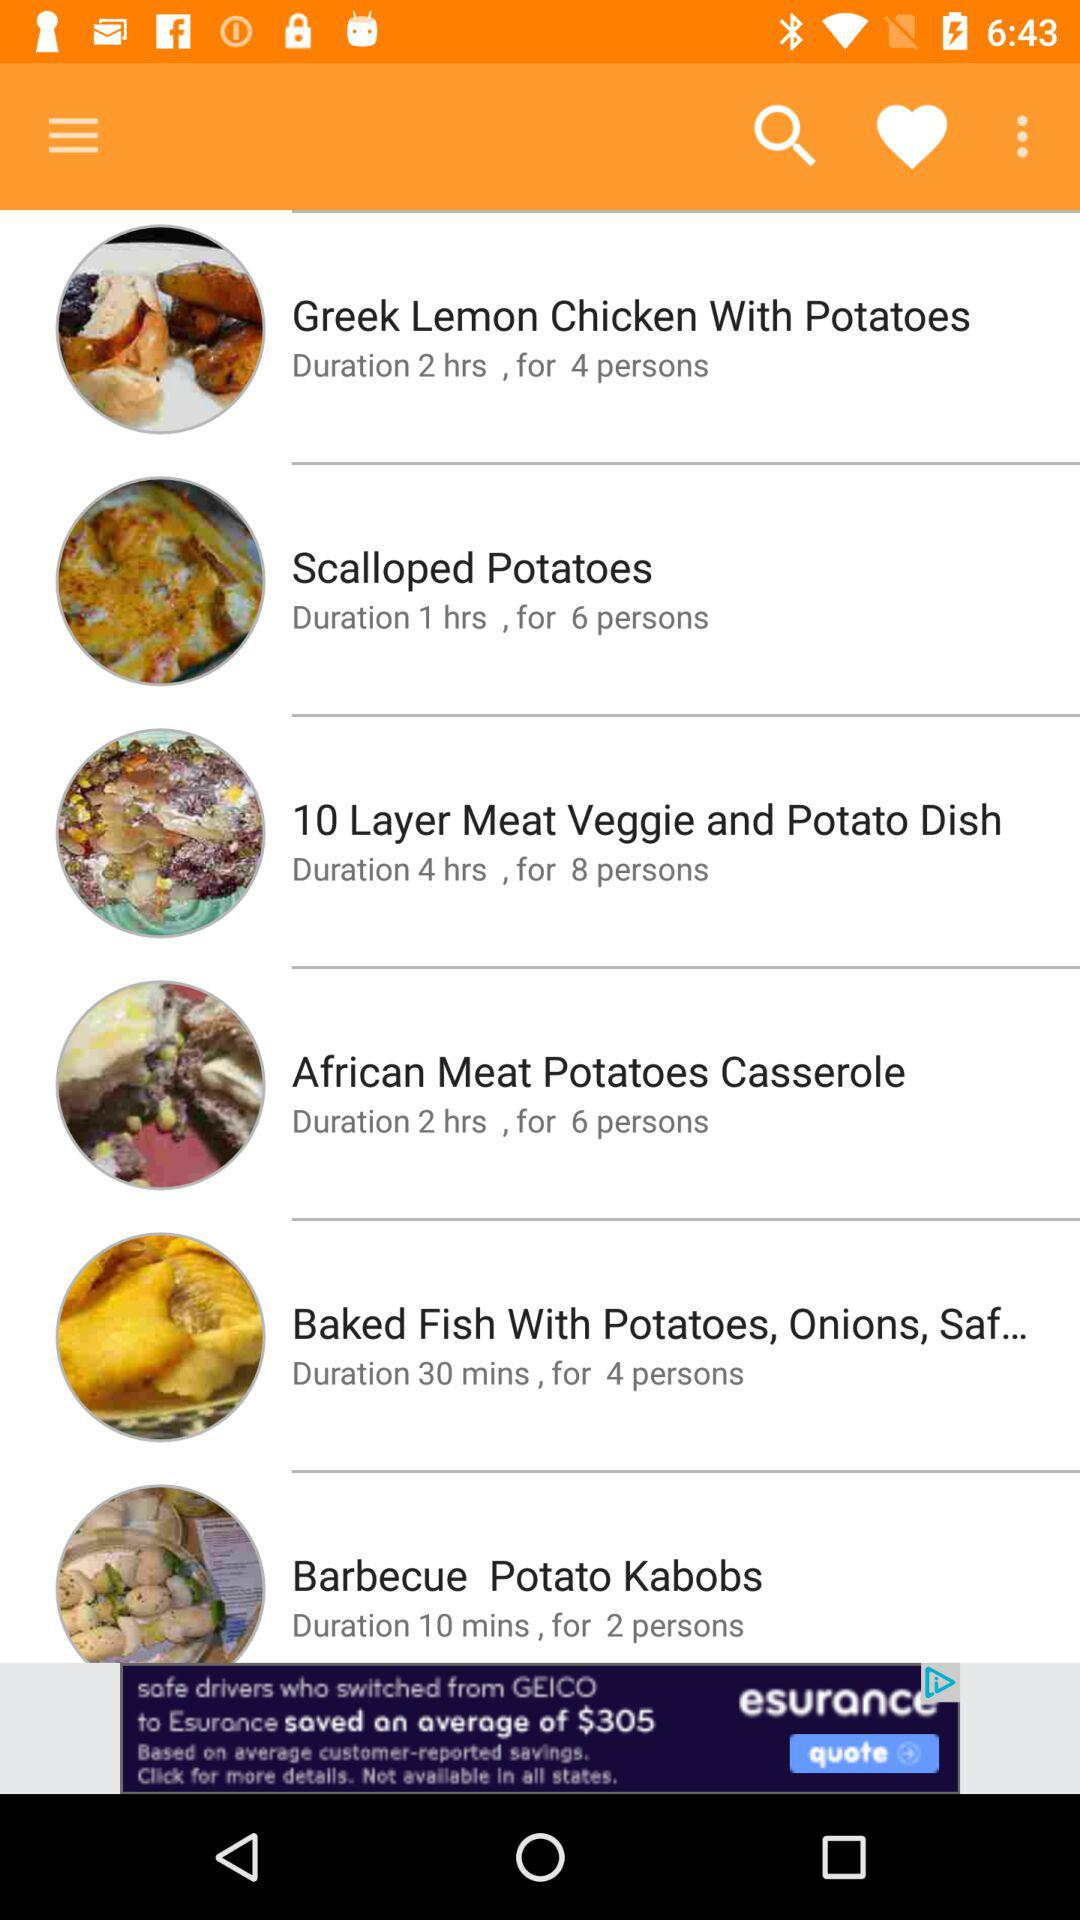How much time does an African meat potatoes casserole take to prepare? An African meat potatoes casserole takes 2 hours to prepare. 